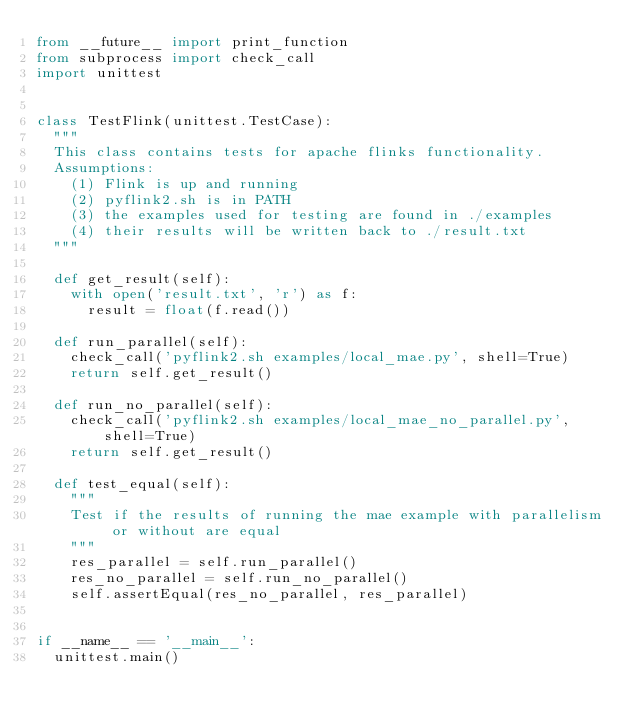<code> <loc_0><loc_0><loc_500><loc_500><_Python_>from __future__ import print_function
from subprocess import check_call
import unittest


class TestFlink(unittest.TestCase):
  """
  This class contains tests for apache flinks functionality.
  Assumptions:
    (1) Flink is up and running
    (2) pyflink2.sh is in PATH
    (3) the examples used for testing are found in ./examples
    (4) their results will be written back to ./result.txt
  """

  def get_result(self):
    with open('result.txt', 'r') as f:
      result = float(f.read())

  def run_parallel(self):
    check_call('pyflink2.sh examples/local_mae.py', shell=True)
    return self.get_result()

  def run_no_parallel(self):
    check_call('pyflink2.sh examples/local_mae_no_parallel.py', shell=True)
    return self.get_result()

  def test_equal(self):
    """
    Test if the results of running the mae example with parallelism or without are equal
    """
    res_parallel = self.run_parallel()
    res_no_parallel = self.run_no_parallel()
    self.assertEqual(res_no_parallel, res_parallel)


if __name__ == '__main__':
  unittest.main()
</code> 